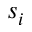Convert formula to latex. <formula><loc_0><loc_0><loc_500><loc_500>s _ { i }</formula> 